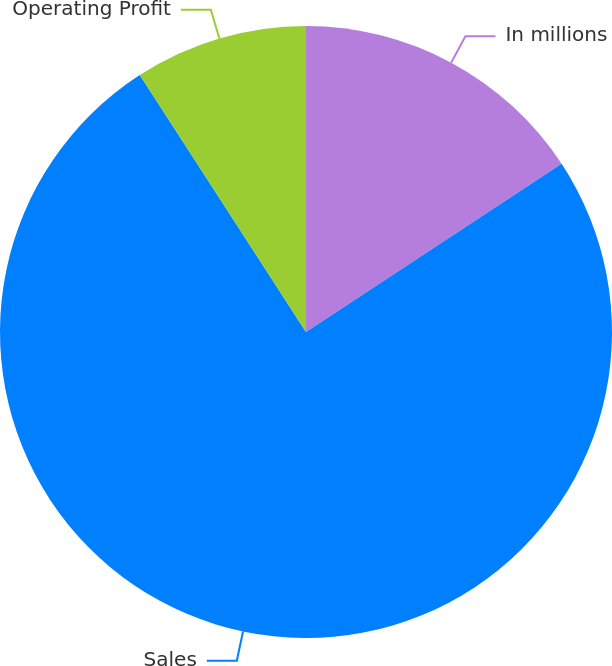Convert chart. <chart><loc_0><loc_0><loc_500><loc_500><pie_chart><fcel>In millions<fcel>Sales<fcel>Operating Profit<nl><fcel>15.74%<fcel>75.13%<fcel>9.14%<nl></chart> 